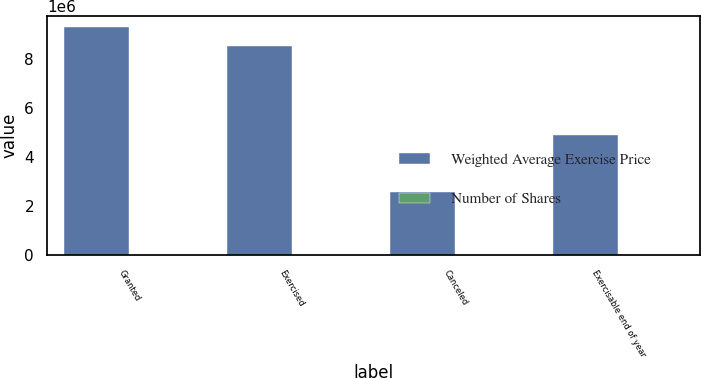Convert chart. <chart><loc_0><loc_0><loc_500><loc_500><stacked_bar_chart><ecel><fcel>Granted<fcel>Exercised<fcel>Canceled<fcel>Exercisable end of year<nl><fcel>Weighted Average Exercise Price<fcel>9.29404e+06<fcel>8.5214e+06<fcel>2.57976e+06<fcel>4.89974e+06<nl><fcel>Number of Shares<fcel>59.35<fcel>14.99<fcel>18.12<fcel>15.84<nl></chart> 